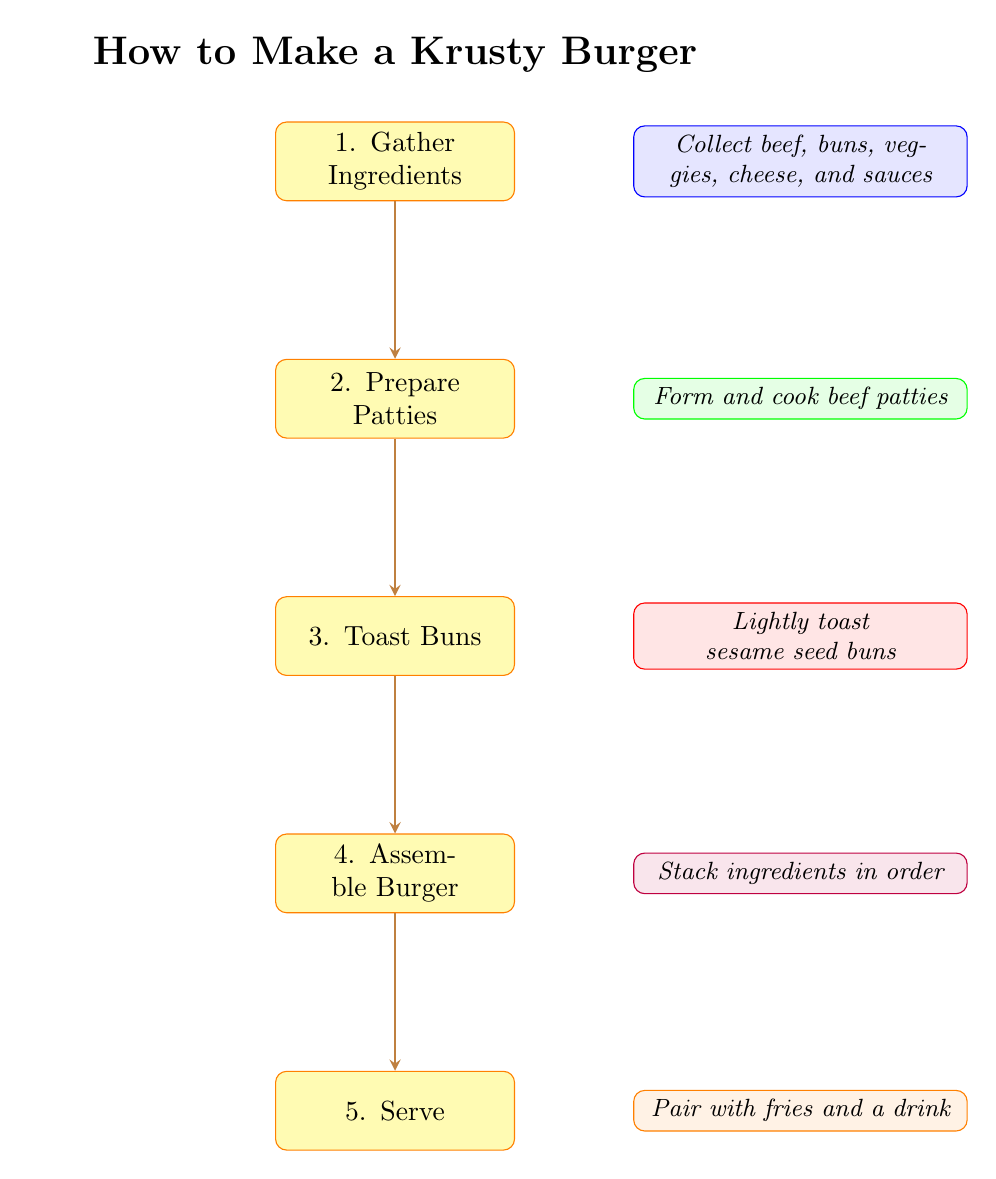What is the first step in making a Krusty Burger? The first step in the flowchart is labeled "1. Gather Ingredients," indicating that this is the initial action required.
Answer: Gather Ingredients How many steps are there in the process? The flowchart contains a total of five distinct steps, each representing a part of the burger-making process.
Answer: 5 Which step involves forming the burger patties? The second step in the flowchart is labeled "2. Prepare Patties," which directly describes the action of forming the patties.
Answer: Prepare Patties What is the last step in the process? The final step in the flowchart is labeled "5. Serve," which indicates the conclusion of the burger-making process.
Answer: Serve What comes after toasting the buns? The flowchart shows an arrow leading from "3. Toast Buns" to "4. Assemble Burger," indicating that assembling the burger follows toasting the buns.
Answer: Assemble Burger Which ingredients are collected in the first step? The first step includes the collection of ground beef, sesame seed buns, lettuce, tomatoes, pickles, onions, American cheese, ketchup, mustard, and special Krusty sauce, as detailed in the description.
Answer: Ground beef, sesame seed buns, lettuce, tomatoes, pickles, onions, American cheese, ketchup, mustard, special Krusty sauce How is the flow between the steps structured? The flowchart uses arrows to connect each step in a sequential manner, indicating a linear progression from gathering ingredients to serving the burger.
Answer: Sequential What is the purpose of the second node in the diagram? The second node, labeled "2. Prepare Patties," is designated for the process of forming and cooking the beef patties according to the burger-making instructions.
Answer: Prepare Patties 